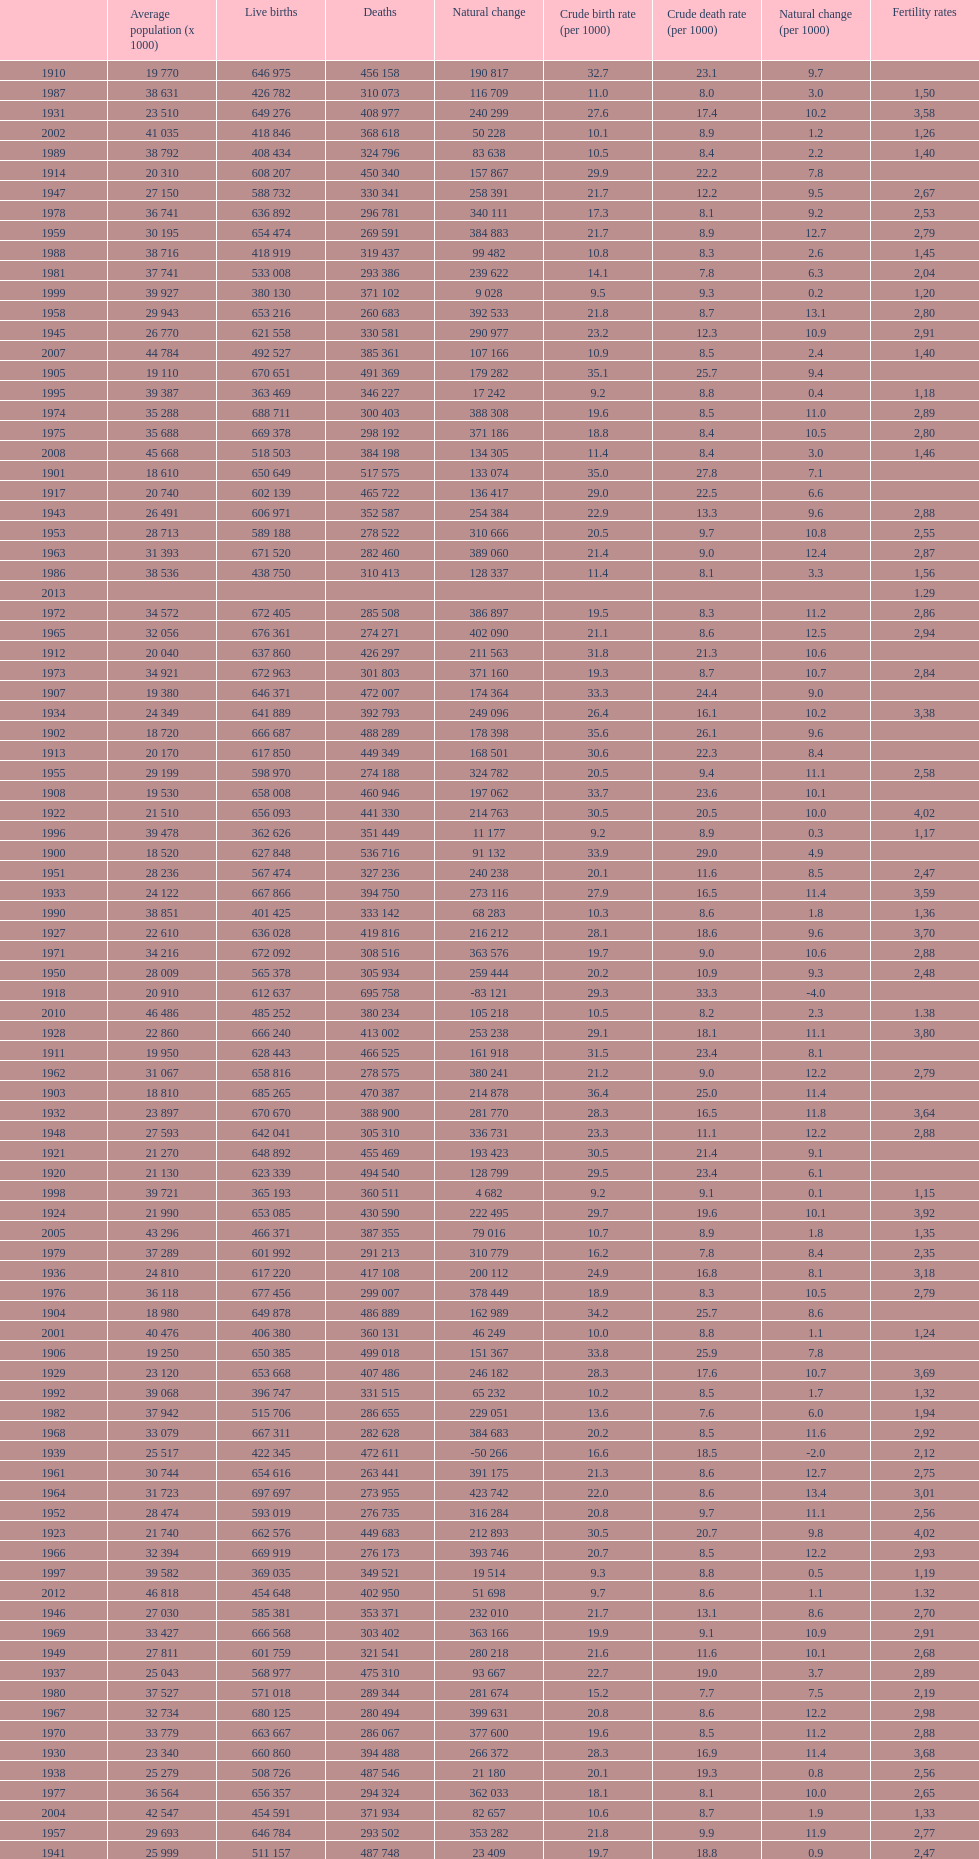Write the full table. {'header': ['', 'Average population (x 1000)', 'Live births', 'Deaths', 'Natural change', 'Crude birth rate (per 1000)', 'Crude death rate (per 1000)', 'Natural change (per 1000)', 'Fertility rates'], 'rows': [['1910', '19 770', '646 975', '456 158', '190 817', '32.7', '23.1', '9.7', ''], ['1987', '38 631', '426 782', '310 073', '116 709', '11.0', '8.0', '3.0', '1,50'], ['1931', '23 510', '649 276', '408 977', '240 299', '27.6', '17.4', '10.2', '3,58'], ['2002', '41 035', '418 846', '368 618', '50 228', '10.1', '8.9', '1.2', '1,26'], ['1989', '38 792', '408 434', '324 796', '83 638', '10.5', '8.4', '2.2', '1,40'], ['1914', '20 310', '608 207', '450 340', '157 867', '29.9', '22.2', '7.8', ''], ['1947', '27 150', '588 732', '330 341', '258 391', '21.7', '12.2', '9.5', '2,67'], ['1978', '36 741', '636 892', '296 781', '340 111', '17.3', '8.1', '9.2', '2,53'], ['1959', '30 195', '654 474', '269 591', '384 883', '21.7', '8.9', '12.7', '2,79'], ['1988', '38 716', '418 919', '319 437', '99 482', '10.8', '8.3', '2.6', '1,45'], ['1981', '37 741', '533 008', '293 386', '239 622', '14.1', '7.8', '6.3', '2,04'], ['1999', '39 927', '380 130', '371 102', '9 028', '9.5', '9.3', '0.2', '1,20'], ['1958', '29 943', '653 216', '260 683', '392 533', '21.8', '8.7', '13.1', '2,80'], ['1945', '26 770', '621 558', '330 581', '290 977', '23.2', '12.3', '10.9', '2,91'], ['2007', '44 784', '492 527', '385 361', '107 166', '10.9', '8.5', '2.4', '1,40'], ['1905', '19 110', '670 651', '491 369', '179 282', '35.1', '25.7', '9.4', ''], ['1995', '39 387', '363 469', '346 227', '17 242', '9.2', '8.8', '0.4', '1,18'], ['1974', '35 288', '688 711', '300 403', '388 308', '19.6', '8.5', '11.0', '2,89'], ['1975', '35 688', '669 378', '298 192', '371 186', '18.8', '8.4', '10.5', '2,80'], ['2008', '45 668', '518 503', '384 198', '134 305', '11.4', '8.4', '3.0', '1,46'], ['1901', '18 610', '650 649', '517 575', '133 074', '35.0', '27.8', '7.1', ''], ['1917', '20 740', '602 139', '465 722', '136 417', '29.0', '22.5', '6.6', ''], ['1943', '26 491', '606 971', '352 587', '254 384', '22.9', '13.3', '9.6', '2,88'], ['1953', '28 713', '589 188', '278 522', '310 666', '20.5', '9.7', '10.8', '2,55'], ['1963', '31 393', '671 520', '282 460', '389 060', '21.4', '9.0', '12.4', '2,87'], ['1986', '38 536', '438 750', '310 413', '128 337', '11.4', '8.1', '3.3', '1,56'], ['2013', '', '', '', '', '', '', '', '1.29'], ['1972', '34 572', '672 405', '285 508', '386 897', '19.5', '8.3', '11.2', '2,86'], ['1965', '32 056', '676 361', '274 271', '402 090', '21.1', '8.6', '12.5', '2,94'], ['1912', '20 040', '637 860', '426 297', '211 563', '31.8', '21.3', '10.6', ''], ['1973', '34 921', '672 963', '301 803', '371 160', '19.3', '8.7', '10.7', '2,84'], ['1907', '19 380', '646 371', '472 007', '174 364', '33.3', '24.4', '9.0', ''], ['1934', '24 349', '641 889', '392 793', '249 096', '26.4', '16.1', '10.2', '3,38'], ['1902', '18 720', '666 687', '488 289', '178 398', '35.6', '26.1', '9.6', ''], ['1913', '20 170', '617 850', '449 349', '168 501', '30.6', '22.3', '8.4', ''], ['1955', '29 199', '598 970', '274 188', '324 782', '20.5', '9.4', '11.1', '2,58'], ['1908', '19 530', '658 008', '460 946', '197 062', '33.7', '23.6', '10.1', ''], ['1922', '21 510', '656 093', '441 330', '214 763', '30.5', '20.5', '10.0', '4,02'], ['1996', '39 478', '362 626', '351 449', '11 177', '9.2', '8.9', '0.3', '1,17'], ['1900', '18 520', '627 848', '536 716', '91 132', '33.9', '29.0', '4.9', ''], ['1951', '28 236', '567 474', '327 236', '240 238', '20.1', '11.6', '8.5', '2,47'], ['1933', '24 122', '667 866', '394 750', '273 116', '27.9', '16.5', '11.4', '3,59'], ['1990', '38 851', '401 425', '333 142', '68 283', '10.3', '8.6', '1.8', '1,36'], ['1927', '22 610', '636 028', '419 816', '216 212', '28.1', '18.6', '9.6', '3,70'], ['1971', '34 216', '672 092', '308 516', '363 576', '19.7', '9.0', '10.6', '2,88'], ['1950', '28 009', '565 378', '305 934', '259 444', '20.2', '10.9', '9.3', '2,48'], ['1918', '20 910', '612 637', '695 758', '-83 121', '29.3', '33.3', '-4.0', ''], ['2010', '46 486', '485 252', '380 234', '105 218', '10.5', '8.2', '2.3', '1.38'], ['1928', '22 860', '666 240', '413 002', '253 238', '29.1', '18.1', '11.1', '3,80'], ['1911', '19 950', '628 443', '466 525', '161 918', '31.5', '23.4', '8.1', ''], ['1962', '31 067', '658 816', '278 575', '380 241', '21.2', '9.0', '12.2', '2,79'], ['1903', '18 810', '685 265', '470 387', '214 878', '36.4', '25.0', '11.4', ''], ['1932', '23 897', '670 670', '388 900', '281 770', '28.3', '16.5', '11.8', '3,64'], ['1948', '27 593', '642 041', '305 310', '336 731', '23.3', '11.1', '12.2', '2,88'], ['1921', '21 270', '648 892', '455 469', '193 423', '30.5', '21.4', '9.1', ''], ['1920', '21 130', '623 339', '494 540', '128 799', '29.5', '23.4', '6.1', ''], ['1998', '39 721', '365 193', '360 511', '4 682', '9.2', '9.1', '0.1', '1,15'], ['1924', '21 990', '653 085', '430 590', '222 495', '29.7', '19.6', '10.1', '3,92'], ['2005', '43 296', '466 371', '387 355', '79 016', '10.7', '8.9', '1.8', '1,35'], ['1979', '37 289', '601 992', '291 213', '310 779', '16.2', '7.8', '8.4', '2,35'], ['1936', '24 810', '617 220', '417 108', '200 112', '24.9', '16.8', '8.1', '3,18'], ['1976', '36 118', '677 456', '299 007', '378 449', '18.9', '8.3', '10.5', '2,79'], ['1904', '18 980', '649 878', '486 889', '162 989', '34.2', '25.7', '8.6', ''], ['2001', '40 476', '406 380', '360 131', '46 249', '10.0', '8.8', '1.1', '1,24'], ['1906', '19 250', '650 385', '499 018', '151 367', '33.8', '25.9', '7.8', ''], ['1929', '23 120', '653 668', '407 486', '246 182', '28.3', '17.6', '10.7', '3,69'], ['1992', '39 068', '396 747', '331 515', '65 232', '10.2', '8.5', '1.7', '1,32'], ['1982', '37 942', '515 706', '286 655', '229 051', '13.6', '7.6', '6.0', '1,94'], ['1968', '33 079', '667 311', '282 628', '384 683', '20.2', '8.5', '11.6', '2,92'], ['1939', '25 517', '422 345', '472 611', '-50 266', '16.6', '18.5', '-2.0', '2,12'], ['1961', '30 744', '654 616', '263 441', '391 175', '21.3', '8.6', '12.7', '2,75'], ['1964', '31 723', '697 697', '273 955', '423 742', '22.0', '8.6', '13.4', '3,01'], ['1952', '28 474', '593 019', '276 735', '316 284', '20.8', '9.7', '11.1', '2,56'], ['1923', '21 740', '662 576', '449 683', '212 893', '30.5', '20.7', '9.8', '4,02'], ['1966', '32 394', '669 919', '276 173', '393 746', '20.7', '8.5', '12.2', '2,93'], ['1997', '39 582', '369 035', '349 521', '19 514', '9.3', '8.8', '0.5', '1,19'], ['2012', '46 818', '454 648', '402 950', '51 698', '9.7', '8.6', '1.1', '1.32'], ['1946', '27 030', '585 381', '353 371', '232 010', '21.7', '13.1', '8.6', '2,70'], ['1969', '33 427', '666 568', '303 402', '363 166', '19.9', '9.1', '10.9', '2,91'], ['1949', '27 811', '601 759', '321 541', '280 218', '21.6', '11.6', '10.1', '2,68'], ['1937', '25 043', '568 977', '475 310', '93 667', '22.7', '19.0', '3.7', '2,89'], ['1980', '37 527', '571 018', '289 344', '281 674', '15.2', '7.7', '7.5', '2,19'], ['1967', '32 734', '680 125', '280 494', '399 631', '20.8', '8.6', '12.2', '2,98'], ['1970', '33 779', '663 667', '286 067', '377 600', '19.6', '8.5', '11.2', '2,88'], ['1930', '23 340', '660 860', '394 488', '266 372', '28.3', '16.9', '11.4', '3,68'], ['1938', '25 279', '508 726', '487 546', '21 180', '20.1', '19.3', '0.8', '2,56'], ['1977', '36 564', '656 357', '294 324', '362 033', '18.1', '8.1', '10.0', '2,65'], ['2004', '42 547', '454 591', '371 934', '82 657', '10.6', '8.7', '1.9', '1,33'], ['1957', '29 693', '646 784', '293 502', '353 282', '21.8', '9.9', '11.9', '2,77'], ['1941', '25 999', '511 157', '487 748', '23 409', '19.7', '18.8', '0.9', '2,47'], ['1991', '38 940', '395 989', '337 691', '58 298', '10.2', '8.7', '1.5', '1,33'], ['1985', '38 419', '456 298', '312 532', '143 766', '11.9', '8.1', '3.7', '1,64'], ['1919', '21 000', '585 963', '482 752', '103 211', '27.9', '23.0', '4.9', ''], ['2009', '46 239', '493 717', '383 209', '110 508', '10.7', '8.2', '2.5', '1,39'], ['2003', '41 827', '441 881', '384 828', '57 053', '10.5', '9.2', '1.4', '1,31'], ['1993', '39 190', '385 786', '339 661', '46 125', '9.8', '8.7', '1.2', '1,26'], ['1909', '19 670', '650 498', '466 648', '183 850', '33.1', '23.7', '9.3', ''], ['1916', '20 610', '599 011', '441 673', '157 338', '29.1', '21.4', '7.6', ''], ['1984', '38 279', '473 281', '299 409', '173 872', '12.4', '7.8', '4.5', '1,73'], ['1926', '22 400', '663 401', '420 838', '242 563', '29.6', '18.8', '10.8', '3,87'], ['1940', '25 757', '631 285', '428 416', '202 869', '24.5', '16.6', '7.9', '3,09'], ['1994', '39 295', '370 148', '338 242', '31 906', '9.4', '8.6', '0.8', '1,21'], ['1960', '30 455', '663 375', '268 941', '394 434', '21.8', '8.8', '13.0', '2,77'], ['1956', '29 445', '608 121', '290 410', '317 711', '20.7', '9.9', '10.8', '2,61'], ['1935', '24 578', '636 725', '388 757', '247 968', '25.9', '15.8', '10.1', '3,31'], ['1942', '26 244', '530 845', '387 844', '143 001', '20.2', '14.8', '5.4', '2,53'], ['1925', '22 160', '644 741', '432 400', '212 341', '29.1', '19.5', '9.6', '3,82'], ['1915', '20 430', '631 462', '452 479', '178 983', '30.9', '22.1', '8.8', ''], ['1983', '38 122', '485 352', '302 569', '182 783', '12.7', '7.9', '4.8', '1,80'], ['1944', '26 620', '602 091', '349 114', '253 796', '22.6', '13.1', '9.5', '2,84'], ['1954', '28 955', '577 886', '264 668', '313 218', '20.0', '9.1', '10.8', '2,50'], ['2006', '44 009', '482 957', '371 478', '111 479', '10.9', '8.4', '2.5', '1,36'], ['2011', '46 667', '470 553', '386 017', '84 536', '10.2', '8.4', '1.8', '1.34'], ['2000', '40 264', '397 632', '360 391', '37 241', '9.9', '9.0', '0.9', '1,23']]} In which year did spain show the highest number of live births over deaths? 1964. 